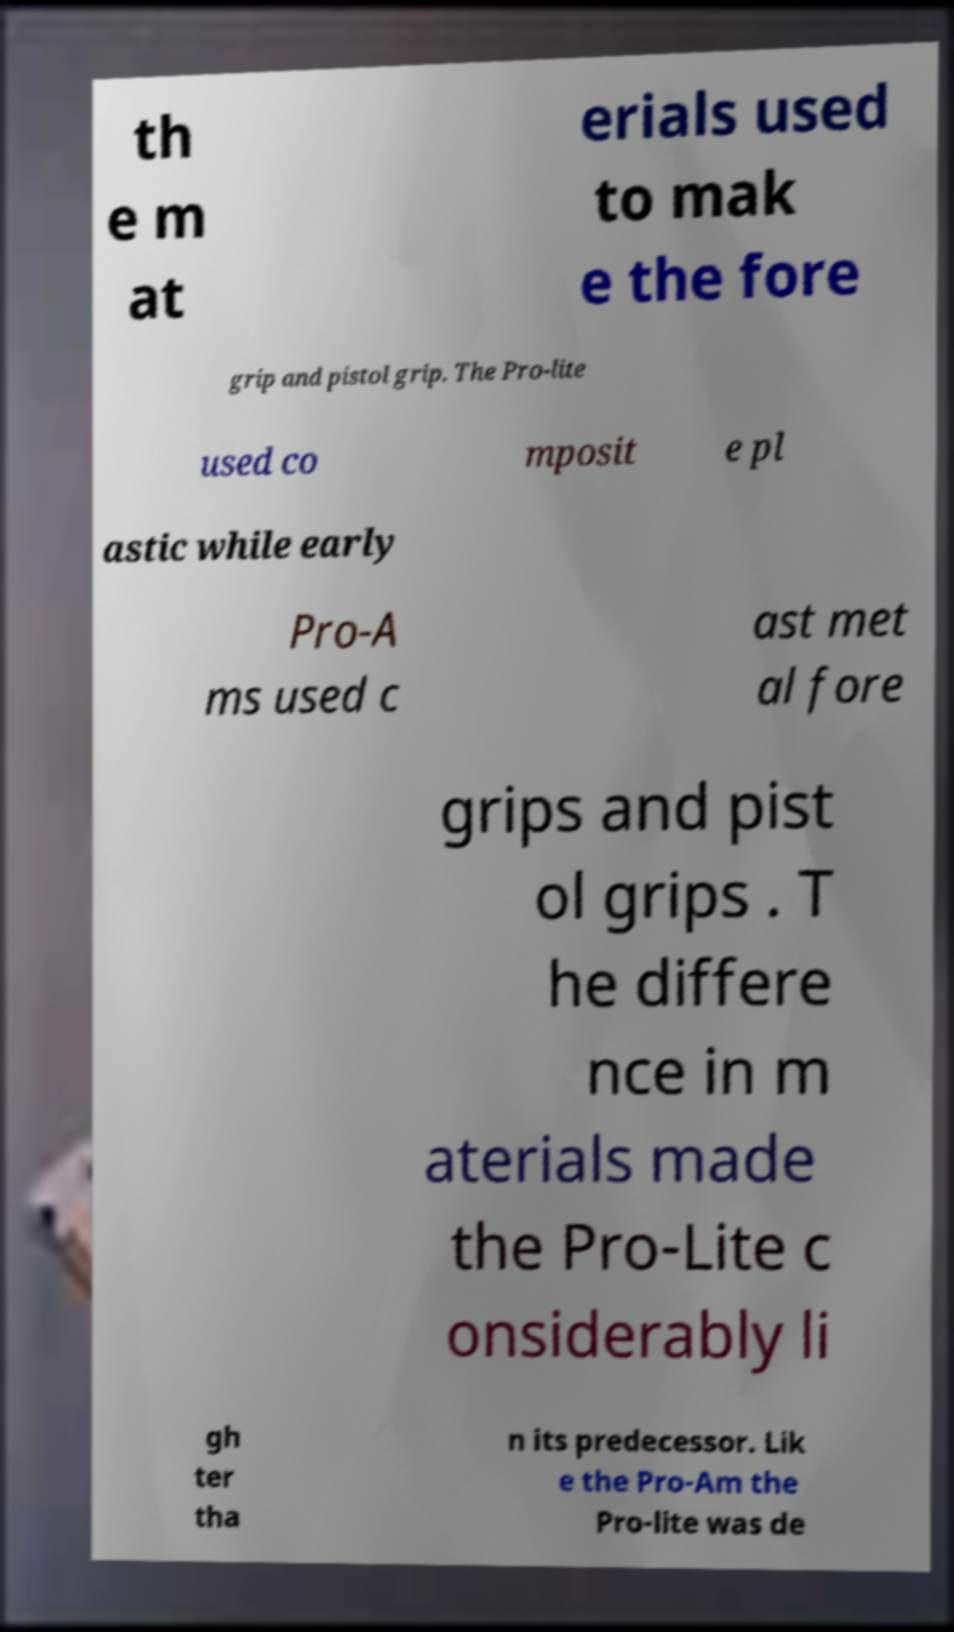There's text embedded in this image that I need extracted. Can you transcribe it verbatim? th e m at erials used to mak e the fore grip and pistol grip. The Pro-lite used co mposit e pl astic while early Pro-A ms used c ast met al fore grips and pist ol grips . T he differe nce in m aterials made the Pro-Lite c onsiderably li gh ter tha n its predecessor. Lik e the Pro-Am the Pro-lite was de 